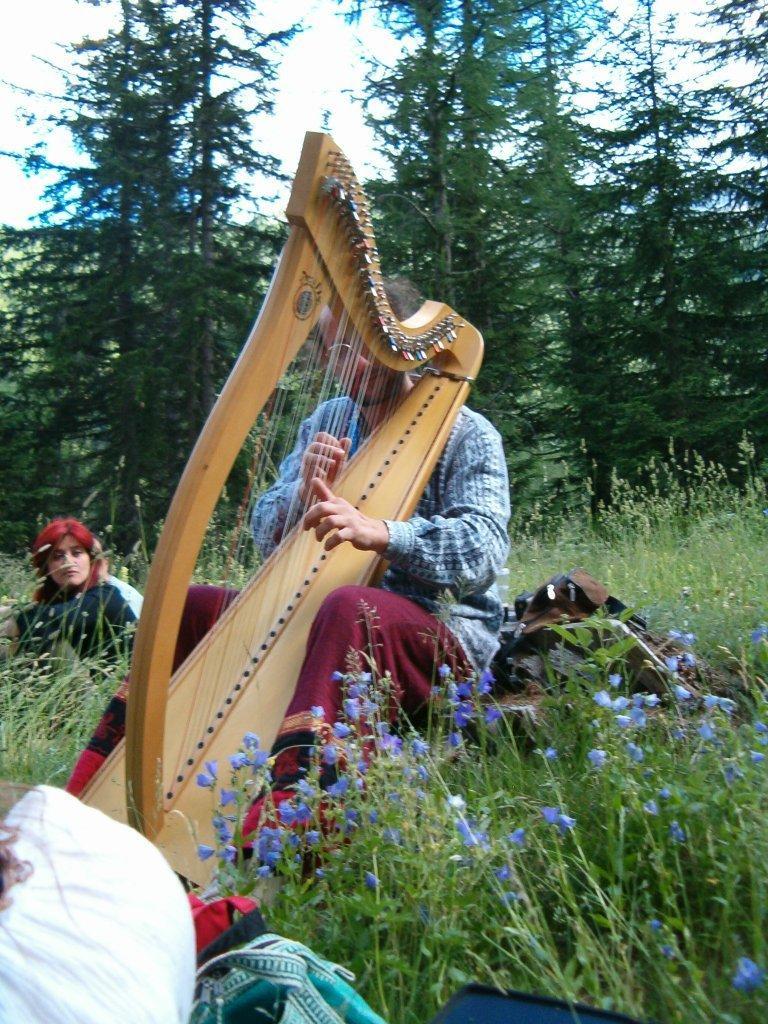Please provide a concise description of this image. In this image I can see few plants, few flowers which are purple in color, few bags, a person sitting and holding a musical instrument and another person sitting. In the background I can see few trees which are green in color and the sky. 